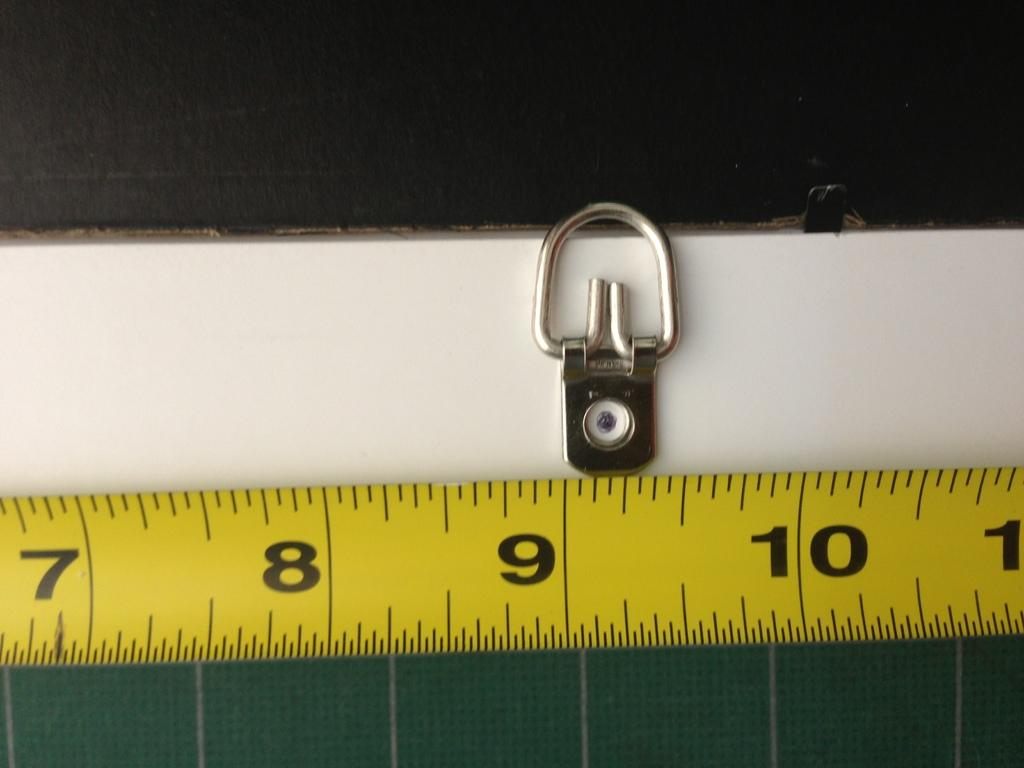<image>
Write a terse but informative summary of the picture. a tape measurer with the numbers seven , eight, nine, and ten 